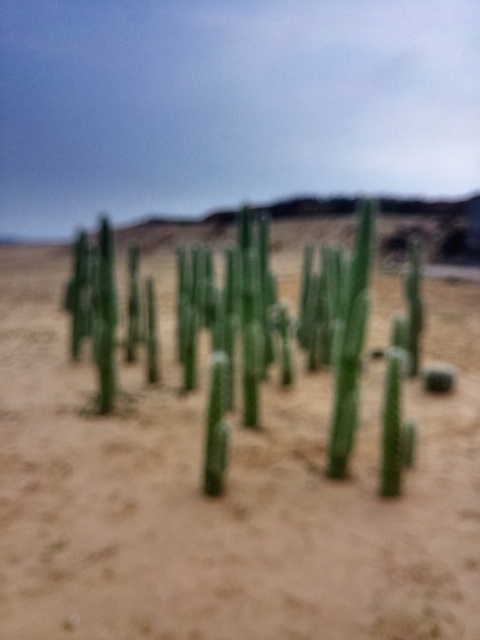Is the photo perfectly focused?
A. No
B. Yes
Answer with the option's letter from the given choices directly.
 A. 